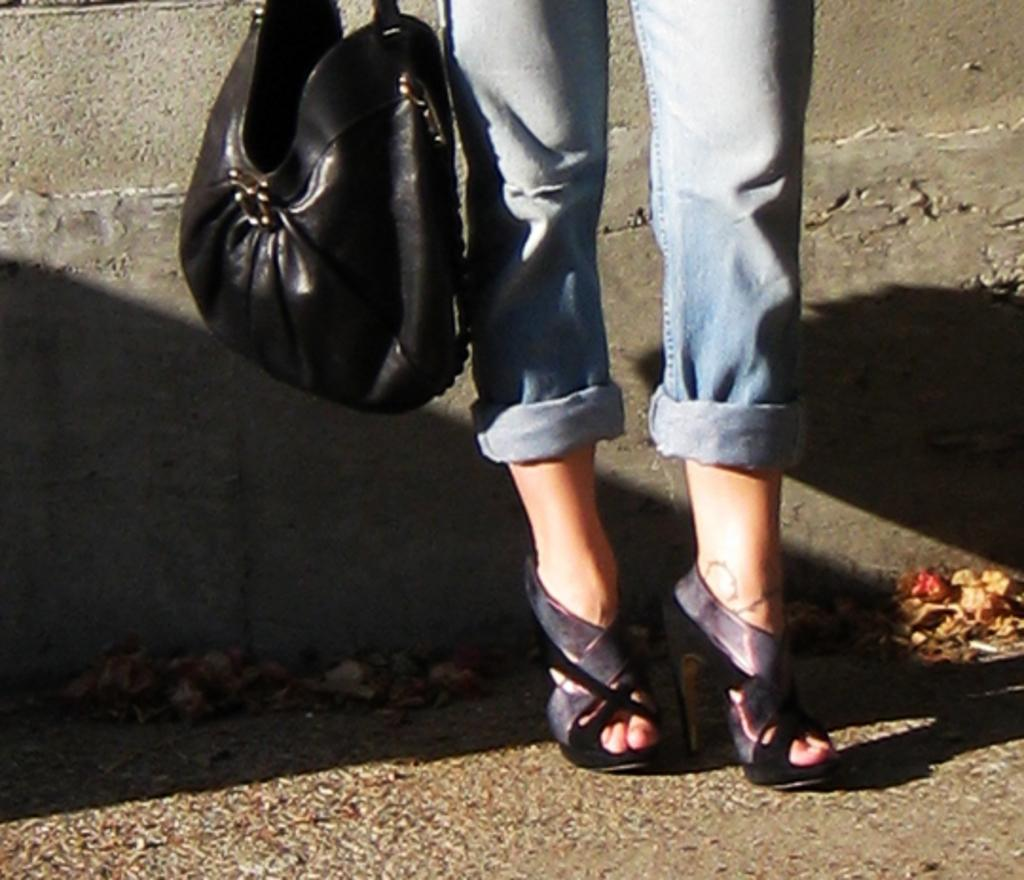What part of the girl can be seen in the image? There are legs of a girl in the image. What type of footwear is the girl wearing? The girl is wearing high heels. What object is beside the girl in the image? There is a black bag beside the girl. When was the image taken, based on the lighting? The image was taken during daylight. What type of cushion is the girl sitting on in the image? There is no cushion present in the image, as only the girl's legs are visible. Is there a lamp visible in the image? No, there is no lamp present in the image. 